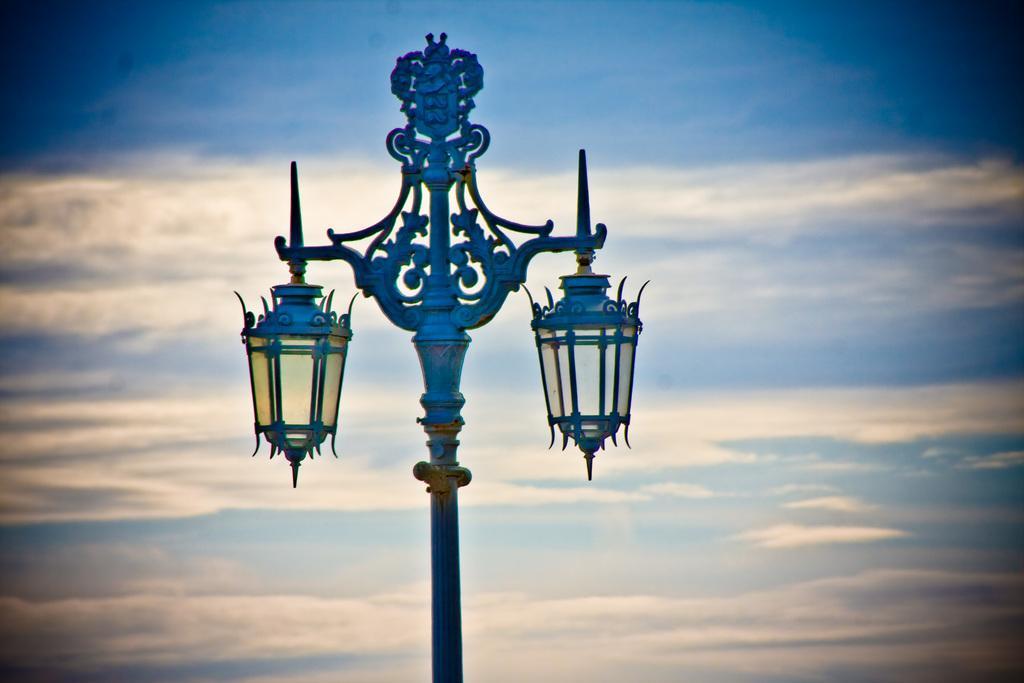Can you describe this image briefly? In this picture we can see a pole,lamps and we can see sky in the background. 